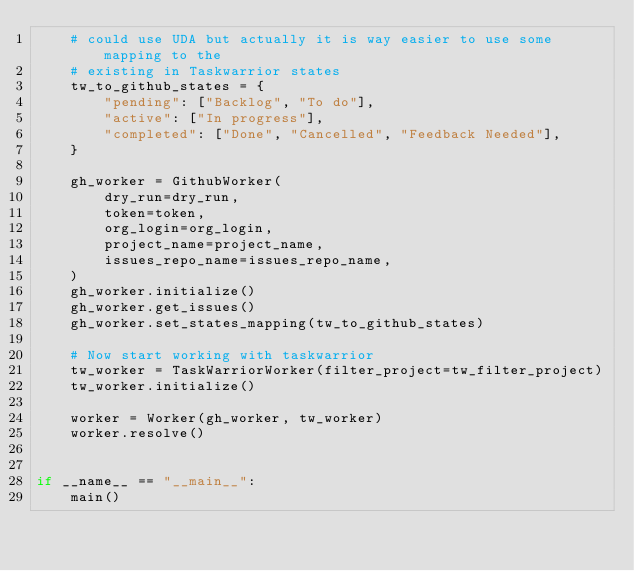Convert code to text. <code><loc_0><loc_0><loc_500><loc_500><_Python_>    # could use UDA but actually it is way easier to use some mapping to the
    # existing in Taskwarrior states
    tw_to_github_states = {
        "pending": ["Backlog", "To do"],
        "active": ["In progress"],
        "completed": ["Done", "Cancelled", "Feedback Needed"],
    }

    gh_worker = GithubWorker(
        dry_run=dry_run,
        token=token,
        org_login=org_login,
        project_name=project_name,
        issues_repo_name=issues_repo_name,
    )
    gh_worker.initialize()
    gh_worker.get_issues()
    gh_worker.set_states_mapping(tw_to_github_states)

    # Now start working with taskwarrior
    tw_worker = TaskWarriorWorker(filter_project=tw_filter_project)
    tw_worker.initialize()

    worker = Worker(gh_worker, tw_worker)
    worker.resolve()


if __name__ == "__main__":
    main()
</code> 